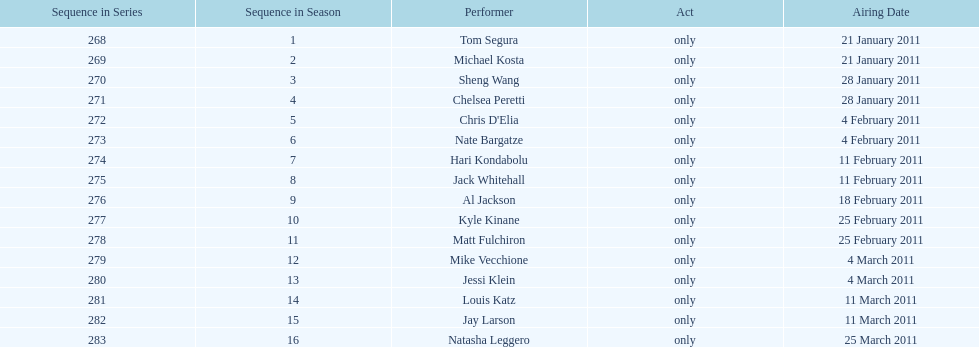What is the total number of unique performers that participated in this season? 16. 